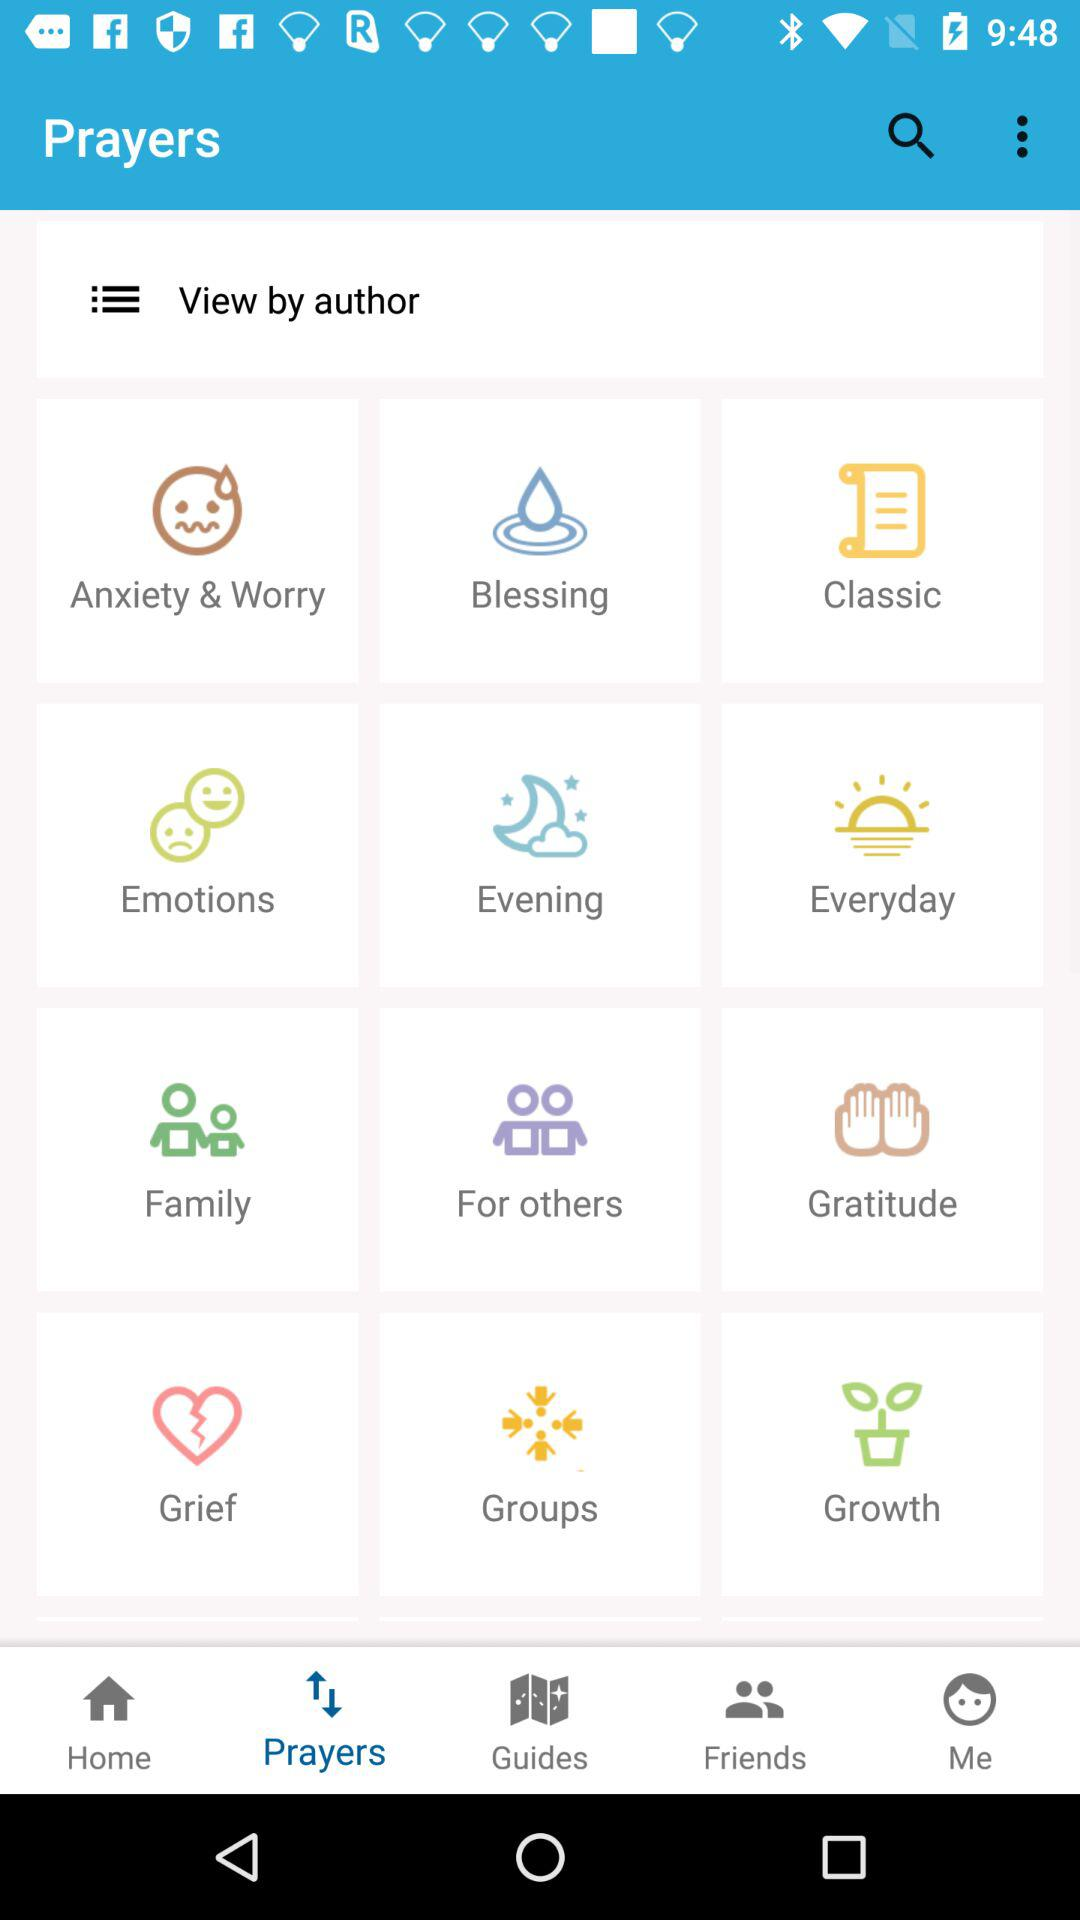What filter is selected for "View by"? The filter that is selected for "View by" is author. 